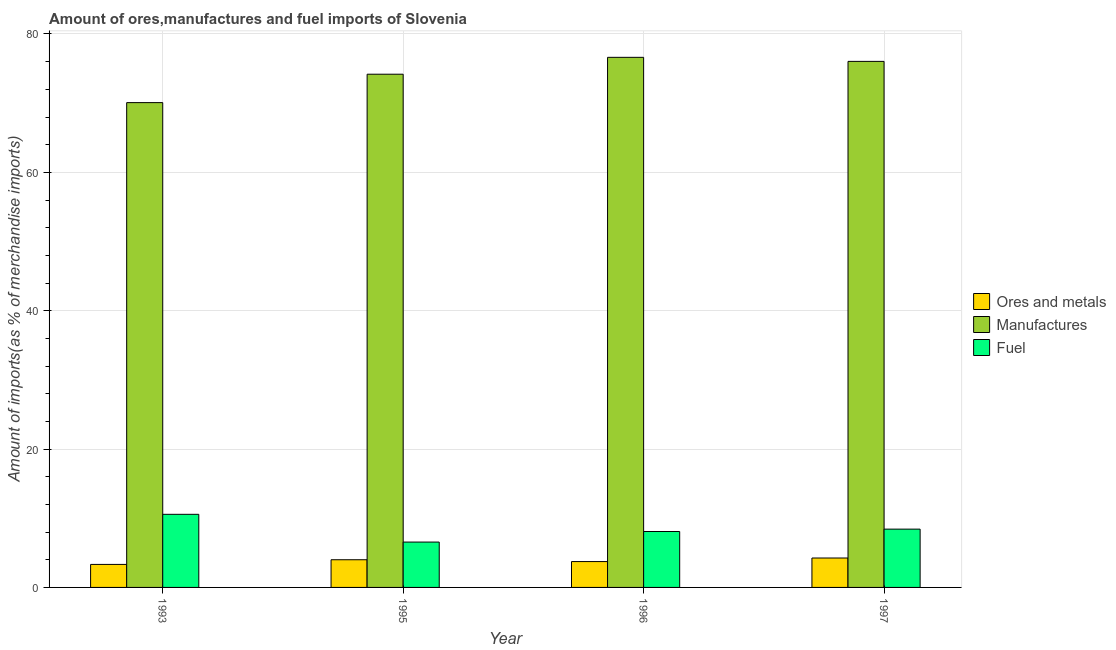How many groups of bars are there?
Offer a very short reply. 4. How many bars are there on the 4th tick from the left?
Provide a short and direct response. 3. In how many cases, is the number of bars for a given year not equal to the number of legend labels?
Give a very brief answer. 0. What is the percentage of ores and metals imports in 1997?
Offer a very short reply. 4.25. Across all years, what is the maximum percentage of ores and metals imports?
Keep it short and to the point. 4.25. Across all years, what is the minimum percentage of manufactures imports?
Your answer should be very brief. 70.08. In which year was the percentage of manufactures imports minimum?
Your answer should be very brief. 1993. What is the total percentage of ores and metals imports in the graph?
Provide a short and direct response. 15.32. What is the difference between the percentage of fuel imports in 1995 and that in 1996?
Your answer should be compact. -1.53. What is the difference between the percentage of ores and metals imports in 1997 and the percentage of fuel imports in 1995?
Make the answer very short. 0.25. What is the average percentage of fuel imports per year?
Keep it short and to the point. 8.41. In how many years, is the percentage of manufactures imports greater than 64 %?
Keep it short and to the point. 4. What is the ratio of the percentage of ores and metals imports in 1993 to that in 1997?
Give a very brief answer. 0.78. Is the percentage of ores and metals imports in 1993 less than that in 1995?
Make the answer very short. Yes. Is the difference between the percentage of ores and metals imports in 1993 and 1995 greater than the difference between the percentage of fuel imports in 1993 and 1995?
Offer a very short reply. No. What is the difference between the highest and the second highest percentage of manufactures imports?
Ensure brevity in your answer.  0.59. What is the difference between the highest and the lowest percentage of fuel imports?
Provide a short and direct response. 4.01. In how many years, is the percentage of manufactures imports greater than the average percentage of manufactures imports taken over all years?
Provide a short and direct response. 2. What does the 3rd bar from the left in 1997 represents?
Your answer should be very brief. Fuel. What does the 2nd bar from the right in 1995 represents?
Keep it short and to the point. Manufactures. Where does the legend appear in the graph?
Your response must be concise. Center right. What is the title of the graph?
Keep it short and to the point. Amount of ores,manufactures and fuel imports of Slovenia. What is the label or title of the Y-axis?
Make the answer very short. Amount of imports(as % of merchandise imports). What is the Amount of imports(as % of merchandise imports) of Ores and metals in 1993?
Provide a succinct answer. 3.33. What is the Amount of imports(as % of merchandise imports) in Manufactures in 1993?
Ensure brevity in your answer.  70.08. What is the Amount of imports(as % of merchandise imports) in Fuel in 1993?
Give a very brief answer. 10.57. What is the Amount of imports(as % of merchandise imports) of Ores and metals in 1995?
Your answer should be very brief. 4. What is the Amount of imports(as % of merchandise imports) in Manufactures in 1995?
Ensure brevity in your answer.  74.19. What is the Amount of imports(as % of merchandise imports) in Fuel in 1995?
Your answer should be very brief. 6.56. What is the Amount of imports(as % of merchandise imports) in Ores and metals in 1996?
Make the answer very short. 3.74. What is the Amount of imports(as % of merchandise imports) in Manufactures in 1996?
Ensure brevity in your answer.  76.63. What is the Amount of imports(as % of merchandise imports) in Fuel in 1996?
Your answer should be compact. 8.08. What is the Amount of imports(as % of merchandise imports) of Ores and metals in 1997?
Provide a succinct answer. 4.25. What is the Amount of imports(as % of merchandise imports) of Manufactures in 1997?
Give a very brief answer. 76.04. What is the Amount of imports(as % of merchandise imports) in Fuel in 1997?
Provide a short and direct response. 8.43. Across all years, what is the maximum Amount of imports(as % of merchandise imports) in Ores and metals?
Provide a short and direct response. 4.25. Across all years, what is the maximum Amount of imports(as % of merchandise imports) of Manufactures?
Offer a terse response. 76.63. Across all years, what is the maximum Amount of imports(as % of merchandise imports) of Fuel?
Keep it short and to the point. 10.57. Across all years, what is the minimum Amount of imports(as % of merchandise imports) in Ores and metals?
Your response must be concise. 3.33. Across all years, what is the minimum Amount of imports(as % of merchandise imports) of Manufactures?
Keep it short and to the point. 70.08. Across all years, what is the minimum Amount of imports(as % of merchandise imports) in Fuel?
Give a very brief answer. 6.56. What is the total Amount of imports(as % of merchandise imports) of Ores and metals in the graph?
Keep it short and to the point. 15.32. What is the total Amount of imports(as % of merchandise imports) of Manufactures in the graph?
Your answer should be compact. 296.93. What is the total Amount of imports(as % of merchandise imports) in Fuel in the graph?
Your response must be concise. 33.63. What is the difference between the Amount of imports(as % of merchandise imports) in Ores and metals in 1993 and that in 1995?
Give a very brief answer. -0.67. What is the difference between the Amount of imports(as % of merchandise imports) in Manufactures in 1993 and that in 1995?
Provide a short and direct response. -4.11. What is the difference between the Amount of imports(as % of merchandise imports) in Fuel in 1993 and that in 1995?
Offer a terse response. 4.01. What is the difference between the Amount of imports(as % of merchandise imports) of Ores and metals in 1993 and that in 1996?
Offer a very short reply. -0.41. What is the difference between the Amount of imports(as % of merchandise imports) in Manufactures in 1993 and that in 1996?
Offer a very short reply. -6.55. What is the difference between the Amount of imports(as % of merchandise imports) in Fuel in 1993 and that in 1996?
Keep it short and to the point. 2.48. What is the difference between the Amount of imports(as % of merchandise imports) of Ores and metals in 1993 and that in 1997?
Make the answer very short. -0.93. What is the difference between the Amount of imports(as % of merchandise imports) in Manufactures in 1993 and that in 1997?
Offer a terse response. -5.96. What is the difference between the Amount of imports(as % of merchandise imports) in Fuel in 1993 and that in 1997?
Your response must be concise. 2.14. What is the difference between the Amount of imports(as % of merchandise imports) of Ores and metals in 1995 and that in 1996?
Your answer should be compact. 0.27. What is the difference between the Amount of imports(as % of merchandise imports) in Manufactures in 1995 and that in 1996?
Your answer should be compact. -2.44. What is the difference between the Amount of imports(as % of merchandise imports) of Fuel in 1995 and that in 1996?
Offer a very short reply. -1.53. What is the difference between the Amount of imports(as % of merchandise imports) of Ores and metals in 1995 and that in 1997?
Ensure brevity in your answer.  -0.25. What is the difference between the Amount of imports(as % of merchandise imports) of Manufactures in 1995 and that in 1997?
Offer a very short reply. -1.85. What is the difference between the Amount of imports(as % of merchandise imports) in Fuel in 1995 and that in 1997?
Offer a very short reply. -1.87. What is the difference between the Amount of imports(as % of merchandise imports) of Ores and metals in 1996 and that in 1997?
Give a very brief answer. -0.52. What is the difference between the Amount of imports(as % of merchandise imports) in Manufactures in 1996 and that in 1997?
Keep it short and to the point. 0.59. What is the difference between the Amount of imports(as % of merchandise imports) of Fuel in 1996 and that in 1997?
Provide a short and direct response. -0.34. What is the difference between the Amount of imports(as % of merchandise imports) in Ores and metals in 1993 and the Amount of imports(as % of merchandise imports) in Manufactures in 1995?
Offer a very short reply. -70.86. What is the difference between the Amount of imports(as % of merchandise imports) in Ores and metals in 1993 and the Amount of imports(as % of merchandise imports) in Fuel in 1995?
Your answer should be very brief. -3.23. What is the difference between the Amount of imports(as % of merchandise imports) in Manufactures in 1993 and the Amount of imports(as % of merchandise imports) in Fuel in 1995?
Your answer should be very brief. 63.52. What is the difference between the Amount of imports(as % of merchandise imports) in Ores and metals in 1993 and the Amount of imports(as % of merchandise imports) in Manufactures in 1996?
Offer a terse response. -73.3. What is the difference between the Amount of imports(as % of merchandise imports) of Ores and metals in 1993 and the Amount of imports(as % of merchandise imports) of Fuel in 1996?
Offer a very short reply. -4.76. What is the difference between the Amount of imports(as % of merchandise imports) of Manufactures in 1993 and the Amount of imports(as % of merchandise imports) of Fuel in 1996?
Keep it short and to the point. 62. What is the difference between the Amount of imports(as % of merchandise imports) of Ores and metals in 1993 and the Amount of imports(as % of merchandise imports) of Manufactures in 1997?
Offer a very short reply. -72.71. What is the difference between the Amount of imports(as % of merchandise imports) of Ores and metals in 1993 and the Amount of imports(as % of merchandise imports) of Fuel in 1997?
Keep it short and to the point. -5.1. What is the difference between the Amount of imports(as % of merchandise imports) of Manufactures in 1993 and the Amount of imports(as % of merchandise imports) of Fuel in 1997?
Your answer should be very brief. 61.65. What is the difference between the Amount of imports(as % of merchandise imports) of Ores and metals in 1995 and the Amount of imports(as % of merchandise imports) of Manufactures in 1996?
Give a very brief answer. -72.62. What is the difference between the Amount of imports(as % of merchandise imports) of Ores and metals in 1995 and the Amount of imports(as % of merchandise imports) of Fuel in 1996?
Offer a terse response. -4.08. What is the difference between the Amount of imports(as % of merchandise imports) of Manufactures in 1995 and the Amount of imports(as % of merchandise imports) of Fuel in 1996?
Your answer should be compact. 66.1. What is the difference between the Amount of imports(as % of merchandise imports) in Ores and metals in 1995 and the Amount of imports(as % of merchandise imports) in Manufactures in 1997?
Offer a terse response. -72.04. What is the difference between the Amount of imports(as % of merchandise imports) in Ores and metals in 1995 and the Amount of imports(as % of merchandise imports) in Fuel in 1997?
Offer a very short reply. -4.42. What is the difference between the Amount of imports(as % of merchandise imports) of Manufactures in 1995 and the Amount of imports(as % of merchandise imports) of Fuel in 1997?
Provide a succinct answer. 65.76. What is the difference between the Amount of imports(as % of merchandise imports) of Ores and metals in 1996 and the Amount of imports(as % of merchandise imports) of Manufactures in 1997?
Offer a terse response. -72.3. What is the difference between the Amount of imports(as % of merchandise imports) of Ores and metals in 1996 and the Amount of imports(as % of merchandise imports) of Fuel in 1997?
Your answer should be compact. -4.69. What is the difference between the Amount of imports(as % of merchandise imports) in Manufactures in 1996 and the Amount of imports(as % of merchandise imports) in Fuel in 1997?
Provide a short and direct response. 68.2. What is the average Amount of imports(as % of merchandise imports) of Ores and metals per year?
Offer a very short reply. 3.83. What is the average Amount of imports(as % of merchandise imports) in Manufactures per year?
Your answer should be very brief. 74.23. What is the average Amount of imports(as % of merchandise imports) in Fuel per year?
Your response must be concise. 8.41. In the year 1993, what is the difference between the Amount of imports(as % of merchandise imports) of Ores and metals and Amount of imports(as % of merchandise imports) of Manufactures?
Provide a succinct answer. -66.75. In the year 1993, what is the difference between the Amount of imports(as % of merchandise imports) of Ores and metals and Amount of imports(as % of merchandise imports) of Fuel?
Make the answer very short. -7.24. In the year 1993, what is the difference between the Amount of imports(as % of merchandise imports) of Manufactures and Amount of imports(as % of merchandise imports) of Fuel?
Your answer should be very brief. 59.51. In the year 1995, what is the difference between the Amount of imports(as % of merchandise imports) in Ores and metals and Amount of imports(as % of merchandise imports) in Manufactures?
Provide a succinct answer. -70.19. In the year 1995, what is the difference between the Amount of imports(as % of merchandise imports) in Ores and metals and Amount of imports(as % of merchandise imports) in Fuel?
Keep it short and to the point. -2.55. In the year 1995, what is the difference between the Amount of imports(as % of merchandise imports) of Manufactures and Amount of imports(as % of merchandise imports) of Fuel?
Ensure brevity in your answer.  67.63. In the year 1996, what is the difference between the Amount of imports(as % of merchandise imports) in Ores and metals and Amount of imports(as % of merchandise imports) in Manufactures?
Offer a very short reply. -72.89. In the year 1996, what is the difference between the Amount of imports(as % of merchandise imports) of Ores and metals and Amount of imports(as % of merchandise imports) of Fuel?
Provide a short and direct response. -4.35. In the year 1996, what is the difference between the Amount of imports(as % of merchandise imports) in Manufactures and Amount of imports(as % of merchandise imports) in Fuel?
Provide a short and direct response. 68.54. In the year 1997, what is the difference between the Amount of imports(as % of merchandise imports) in Ores and metals and Amount of imports(as % of merchandise imports) in Manufactures?
Keep it short and to the point. -71.79. In the year 1997, what is the difference between the Amount of imports(as % of merchandise imports) of Ores and metals and Amount of imports(as % of merchandise imports) of Fuel?
Offer a terse response. -4.17. In the year 1997, what is the difference between the Amount of imports(as % of merchandise imports) of Manufactures and Amount of imports(as % of merchandise imports) of Fuel?
Offer a very short reply. 67.61. What is the ratio of the Amount of imports(as % of merchandise imports) in Ores and metals in 1993 to that in 1995?
Your response must be concise. 0.83. What is the ratio of the Amount of imports(as % of merchandise imports) of Manufactures in 1993 to that in 1995?
Provide a succinct answer. 0.94. What is the ratio of the Amount of imports(as % of merchandise imports) of Fuel in 1993 to that in 1995?
Offer a terse response. 1.61. What is the ratio of the Amount of imports(as % of merchandise imports) in Ores and metals in 1993 to that in 1996?
Keep it short and to the point. 0.89. What is the ratio of the Amount of imports(as % of merchandise imports) of Manufactures in 1993 to that in 1996?
Your answer should be very brief. 0.91. What is the ratio of the Amount of imports(as % of merchandise imports) of Fuel in 1993 to that in 1996?
Make the answer very short. 1.31. What is the ratio of the Amount of imports(as % of merchandise imports) of Ores and metals in 1993 to that in 1997?
Give a very brief answer. 0.78. What is the ratio of the Amount of imports(as % of merchandise imports) of Manufactures in 1993 to that in 1997?
Provide a succinct answer. 0.92. What is the ratio of the Amount of imports(as % of merchandise imports) of Fuel in 1993 to that in 1997?
Offer a terse response. 1.25. What is the ratio of the Amount of imports(as % of merchandise imports) in Ores and metals in 1995 to that in 1996?
Your answer should be very brief. 1.07. What is the ratio of the Amount of imports(as % of merchandise imports) of Manufactures in 1995 to that in 1996?
Provide a succinct answer. 0.97. What is the ratio of the Amount of imports(as % of merchandise imports) of Fuel in 1995 to that in 1996?
Keep it short and to the point. 0.81. What is the ratio of the Amount of imports(as % of merchandise imports) in Ores and metals in 1995 to that in 1997?
Your response must be concise. 0.94. What is the ratio of the Amount of imports(as % of merchandise imports) in Manufactures in 1995 to that in 1997?
Your answer should be very brief. 0.98. What is the ratio of the Amount of imports(as % of merchandise imports) of Fuel in 1995 to that in 1997?
Offer a terse response. 0.78. What is the ratio of the Amount of imports(as % of merchandise imports) of Ores and metals in 1996 to that in 1997?
Your answer should be very brief. 0.88. What is the ratio of the Amount of imports(as % of merchandise imports) in Manufactures in 1996 to that in 1997?
Offer a very short reply. 1.01. What is the ratio of the Amount of imports(as % of merchandise imports) in Fuel in 1996 to that in 1997?
Offer a very short reply. 0.96. What is the difference between the highest and the second highest Amount of imports(as % of merchandise imports) in Ores and metals?
Offer a terse response. 0.25. What is the difference between the highest and the second highest Amount of imports(as % of merchandise imports) of Manufactures?
Offer a very short reply. 0.59. What is the difference between the highest and the second highest Amount of imports(as % of merchandise imports) in Fuel?
Keep it short and to the point. 2.14. What is the difference between the highest and the lowest Amount of imports(as % of merchandise imports) in Ores and metals?
Offer a terse response. 0.93. What is the difference between the highest and the lowest Amount of imports(as % of merchandise imports) of Manufactures?
Your response must be concise. 6.55. What is the difference between the highest and the lowest Amount of imports(as % of merchandise imports) of Fuel?
Provide a succinct answer. 4.01. 